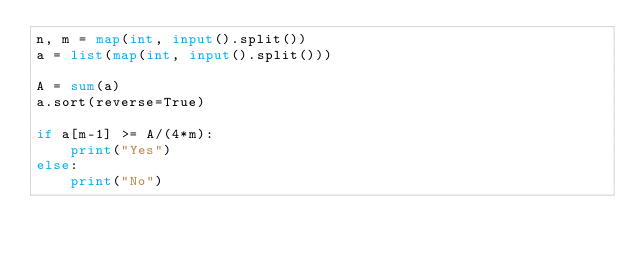<code> <loc_0><loc_0><loc_500><loc_500><_Python_>n, m = map(int, input().split())
a = list(map(int, input().split()))

A = sum(a)
a.sort(reverse=True)

if a[m-1] >= A/(4*m):
    print("Yes")
else:
    print("No")</code> 